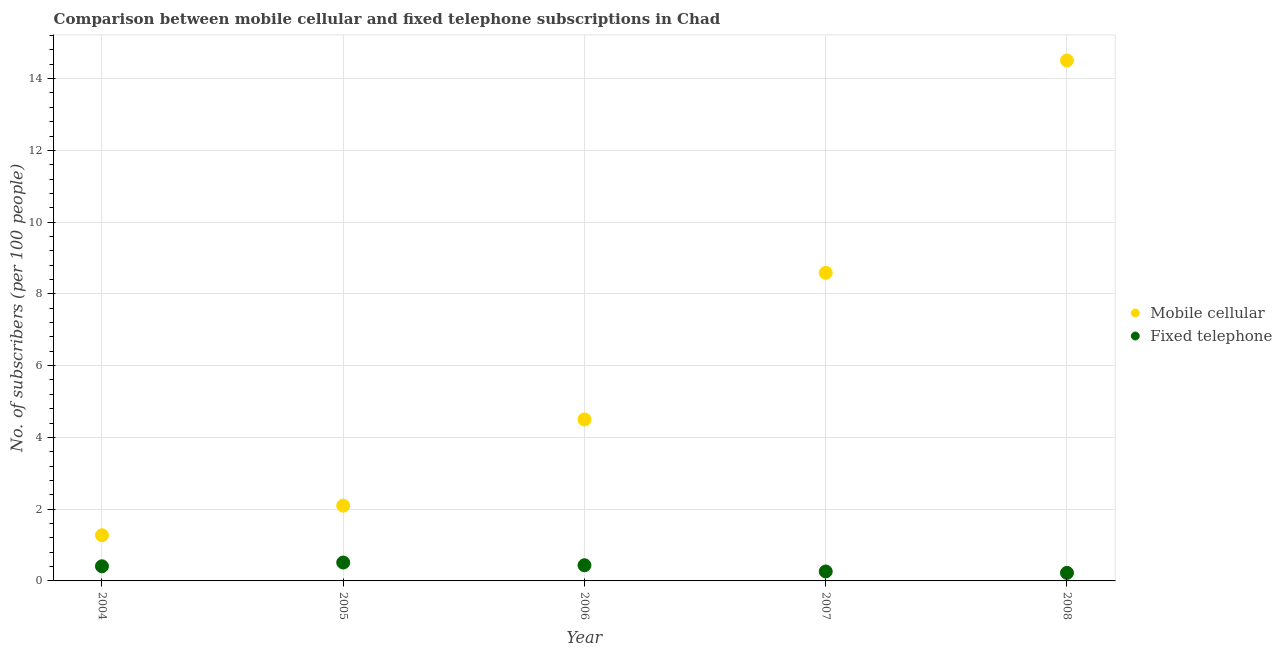How many different coloured dotlines are there?
Offer a terse response. 2. Is the number of dotlines equal to the number of legend labels?
Provide a succinct answer. Yes. What is the number of mobile cellular subscribers in 2004?
Offer a terse response. 1.27. Across all years, what is the maximum number of fixed telephone subscribers?
Your answer should be compact. 0.51. Across all years, what is the minimum number of fixed telephone subscribers?
Your answer should be very brief. 0.22. In which year was the number of fixed telephone subscribers maximum?
Provide a short and direct response. 2005. What is the total number of mobile cellular subscribers in the graph?
Provide a succinct answer. 30.96. What is the difference between the number of mobile cellular subscribers in 2004 and that in 2008?
Provide a succinct answer. -13.23. What is the difference between the number of fixed telephone subscribers in 2007 and the number of mobile cellular subscribers in 2005?
Keep it short and to the point. -1.83. What is the average number of fixed telephone subscribers per year?
Provide a succinct answer. 0.37. In the year 2008, what is the difference between the number of mobile cellular subscribers and number of fixed telephone subscribers?
Your answer should be very brief. 14.28. What is the ratio of the number of fixed telephone subscribers in 2004 to that in 2005?
Your answer should be compact. 0.8. Is the number of mobile cellular subscribers in 2004 less than that in 2006?
Offer a terse response. Yes. Is the difference between the number of fixed telephone subscribers in 2005 and 2008 greater than the difference between the number of mobile cellular subscribers in 2005 and 2008?
Your answer should be very brief. Yes. What is the difference between the highest and the second highest number of fixed telephone subscribers?
Keep it short and to the point. 0.08. What is the difference between the highest and the lowest number of fixed telephone subscribers?
Offer a terse response. 0.29. Is the number of mobile cellular subscribers strictly less than the number of fixed telephone subscribers over the years?
Your answer should be compact. No. How many years are there in the graph?
Offer a terse response. 5. Where does the legend appear in the graph?
Your answer should be very brief. Center right. What is the title of the graph?
Provide a succinct answer. Comparison between mobile cellular and fixed telephone subscriptions in Chad. Does "Private consumption" appear as one of the legend labels in the graph?
Provide a short and direct response. No. What is the label or title of the X-axis?
Ensure brevity in your answer.  Year. What is the label or title of the Y-axis?
Give a very brief answer. No. of subscribers (per 100 people). What is the No. of subscribers (per 100 people) of Mobile cellular in 2004?
Your answer should be compact. 1.27. What is the No. of subscribers (per 100 people) of Fixed telephone in 2004?
Keep it short and to the point. 0.41. What is the No. of subscribers (per 100 people) of Mobile cellular in 2005?
Keep it short and to the point. 2.1. What is the No. of subscribers (per 100 people) of Fixed telephone in 2005?
Keep it short and to the point. 0.51. What is the No. of subscribers (per 100 people) in Mobile cellular in 2006?
Offer a very short reply. 4.5. What is the No. of subscribers (per 100 people) in Fixed telephone in 2006?
Give a very brief answer. 0.44. What is the No. of subscribers (per 100 people) in Mobile cellular in 2007?
Provide a short and direct response. 8.59. What is the No. of subscribers (per 100 people) of Fixed telephone in 2007?
Offer a very short reply. 0.26. What is the No. of subscribers (per 100 people) in Mobile cellular in 2008?
Ensure brevity in your answer.  14.51. What is the No. of subscribers (per 100 people) of Fixed telephone in 2008?
Your response must be concise. 0.22. Across all years, what is the maximum No. of subscribers (per 100 people) in Mobile cellular?
Make the answer very short. 14.51. Across all years, what is the maximum No. of subscribers (per 100 people) in Fixed telephone?
Your answer should be very brief. 0.51. Across all years, what is the minimum No. of subscribers (per 100 people) in Mobile cellular?
Provide a short and direct response. 1.27. Across all years, what is the minimum No. of subscribers (per 100 people) of Fixed telephone?
Offer a terse response. 0.22. What is the total No. of subscribers (per 100 people) of Mobile cellular in the graph?
Your answer should be very brief. 30.96. What is the total No. of subscribers (per 100 people) of Fixed telephone in the graph?
Make the answer very short. 1.85. What is the difference between the No. of subscribers (per 100 people) in Mobile cellular in 2004 and that in 2005?
Your response must be concise. -0.82. What is the difference between the No. of subscribers (per 100 people) of Fixed telephone in 2004 and that in 2005?
Offer a very short reply. -0.1. What is the difference between the No. of subscribers (per 100 people) in Mobile cellular in 2004 and that in 2006?
Offer a very short reply. -3.23. What is the difference between the No. of subscribers (per 100 people) in Fixed telephone in 2004 and that in 2006?
Your answer should be very brief. -0.03. What is the difference between the No. of subscribers (per 100 people) of Mobile cellular in 2004 and that in 2007?
Keep it short and to the point. -7.31. What is the difference between the No. of subscribers (per 100 people) in Fixed telephone in 2004 and that in 2007?
Your answer should be compact. 0.14. What is the difference between the No. of subscribers (per 100 people) in Mobile cellular in 2004 and that in 2008?
Your response must be concise. -13.23. What is the difference between the No. of subscribers (per 100 people) in Fixed telephone in 2004 and that in 2008?
Provide a short and direct response. 0.18. What is the difference between the No. of subscribers (per 100 people) of Mobile cellular in 2005 and that in 2006?
Keep it short and to the point. -2.4. What is the difference between the No. of subscribers (per 100 people) of Fixed telephone in 2005 and that in 2006?
Your answer should be very brief. 0.08. What is the difference between the No. of subscribers (per 100 people) of Mobile cellular in 2005 and that in 2007?
Provide a short and direct response. -6.49. What is the difference between the No. of subscribers (per 100 people) in Fixed telephone in 2005 and that in 2007?
Your response must be concise. 0.25. What is the difference between the No. of subscribers (per 100 people) of Mobile cellular in 2005 and that in 2008?
Give a very brief answer. -12.41. What is the difference between the No. of subscribers (per 100 people) in Fixed telephone in 2005 and that in 2008?
Keep it short and to the point. 0.29. What is the difference between the No. of subscribers (per 100 people) in Mobile cellular in 2006 and that in 2007?
Your answer should be compact. -4.09. What is the difference between the No. of subscribers (per 100 people) of Fixed telephone in 2006 and that in 2007?
Provide a short and direct response. 0.17. What is the difference between the No. of subscribers (per 100 people) of Mobile cellular in 2006 and that in 2008?
Your response must be concise. -10. What is the difference between the No. of subscribers (per 100 people) of Fixed telephone in 2006 and that in 2008?
Keep it short and to the point. 0.21. What is the difference between the No. of subscribers (per 100 people) in Mobile cellular in 2007 and that in 2008?
Make the answer very short. -5.92. What is the difference between the No. of subscribers (per 100 people) of Fixed telephone in 2007 and that in 2008?
Offer a terse response. 0.04. What is the difference between the No. of subscribers (per 100 people) in Mobile cellular in 2004 and the No. of subscribers (per 100 people) in Fixed telephone in 2005?
Your answer should be compact. 0.76. What is the difference between the No. of subscribers (per 100 people) in Mobile cellular in 2004 and the No. of subscribers (per 100 people) in Fixed telephone in 2006?
Give a very brief answer. 0.84. What is the difference between the No. of subscribers (per 100 people) of Mobile cellular in 2004 and the No. of subscribers (per 100 people) of Fixed telephone in 2007?
Offer a very short reply. 1.01. What is the difference between the No. of subscribers (per 100 people) of Mobile cellular in 2004 and the No. of subscribers (per 100 people) of Fixed telephone in 2008?
Your response must be concise. 1.05. What is the difference between the No. of subscribers (per 100 people) of Mobile cellular in 2005 and the No. of subscribers (per 100 people) of Fixed telephone in 2006?
Your answer should be compact. 1.66. What is the difference between the No. of subscribers (per 100 people) in Mobile cellular in 2005 and the No. of subscribers (per 100 people) in Fixed telephone in 2007?
Your answer should be very brief. 1.83. What is the difference between the No. of subscribers (per 100 people) of Mobile cellular in 2005 and the No. of subscribers (per 100 people) of Fixed telephone in 2008?
Keep it short and to the point. 1.87. What is the difference between the No. of subscribers (per 100 people) of Mobile cellular in 2006 and the No. of subscribers (per 100 people) of Fixed telephone in 2007?
Your response must be concise. 4.24. What is the difference between the No. of subscribers (per 100 people) of Mobile cellular in 2006 and the No. of subscribers (per 100 people) of Fixed telephone in 2008?
Your answer should be compact. 4.28. What is the difference between the No. of subscribers (per 100 people) of Mobile cellular in 2007 and the No. of subscribers (per 100 people) of Fixed telephone in 2008?
Give a very brief answer. 8.36. What is the average No. of subscribers (per 100 people) of Mobile cellular per year?
Provide a succinct answer. 6.19. What is the average No. of subscribers (per 100 people) of Fixed telephone per year?
Offer a very short reply. 0.37. In the year 2004, what is the difference between the No. of subscribers (per 100 people) of Mobile cellular and No. of subscribers (per 100 people) of Fixed telephone?
Provide a succinct answer. 0.86. In the year 2005, what is the difference between the No. of subscribers (per 100 people) in Mobile cellular and No. of subscribers (per 100 people) in Fixed telephone?
Provide a short and direct response. 1.58. In the year 2006, what is the difference between the No. of subscribers (per 100 people) of Mobile cellular and No. of subscribers (per 100 people) of Fixed telephone?
Your response must be concise. 4.06. In the year 2007, what is the difference between the No. of subscribers (per 100 people) in Mobile cellular and No. of subscribers (per 100 people) in Fixed telephone?
Offer a terse response. 8.32. In the year 2008, what is the difference between the No. of subscribers (per 100 people) of Mobile cellular and No. of subscribers (per 100 people) of Fixed telephone?
Keep it short and to the point. 14.28. What is the ratio of the No. of subscribers (per 100 people) in Mobile cellular in 2004 to that in 2005?
Your answer should be very brief. 0.61. What is the ratio of the No. of subscribers (per 100 people) of Fixed telephone in 2004 to that in 2005?
Ensure brevity in your answer.  0.8. What is the ratio of the No. of subscribers (per 100 people) of Mobile cellular in 2004 to that in 2006?
Your answer should be very brief. 0.28. What is the ratio of the No. of subscribers (per 100 people) of Fixed telephone in 2004 to that in 2006?
Your answer should be very brief. 0.93. What is the ratio of the No. of subscribers (per 100 people) of Mobile cellular in 2004 to that in 2007?
Make the answer very short. 0.15. What is the ratio of the No. of subscribers (per 100 people) in Fixed telephone in 2004 to that in 2007?
Offer a very short reply. 1.55. What is the ratio of the No. of subscribers (per 100 people) in Mobile cellular in 2004 to that in 2008?
Provide a succinct answer. 0.09. What is the ratio of the No. of subscribers (per 100 people) of Fixed telephone in 2004 to that in 2008?
Keep it short and to the point. 1.82. What is the ratio of the No. of subscribers (per 100 people) of Mobile cellular in 2005 to that in 2006?
Provide a short and direct response. 0.47. What is the ratio of the No. of subscribers (per 100 people) in Fixed telephone in 2005 to that in 2006?
Your answer should be very brief. 1.17. What is the ratio of the No. of subscribers (per 100 people) of Mobile cellular in 2005 to that in 2007?
Provide a succinct answer. 0.24. What is the ratio of the No. of subscribers (per 100 people) in Fixed telephone in 2005 to that in 2007?
Offer a very short reply. 1.94. What is the ratio of the No. of subscribers (per 100 people) in Mobile cellular in 2005 to that in 2008?
Make the answer very short. 0.14. What is the ratio of the No. of subscribers (per 100 people) of Fixed telephone in 2005 to that in 2008?
Keep it short and to the point. 2.28. What is the ratio of the No. of subscribers (per 100 people) in Mobile cellular in 2006 to that in 2007?
Your response must be concise. 0.52. What is the ratio of the No. of subscribers (per 100 people) of Fixed telephone in 2006 to that in 2007?
Give a very brief answer. 1.66. What is the ratio of the No. of subscribers (per 100 people) of Mobile cellular in 2006 to that in 2008?
Your response must be concise. 0.31. What is the ratio of the No. of subscribers (per 100 people) in Fixed telephone in 2006 to that in 2008?
Offer a very short reply. 1.95. What is the ratio of the No. of subscribers (per 100 people) of Mobile cellular in 2007 to that in 2008?
Ensure brevity in your answer.  0.59. What is the ratio of the No. of subscribers (per 100 people) of Fixed telephone in 2007 to that in 2008?
Offer a terse response. 1.17. What is the difference between the highest and the second highest No. of subscribers (per 100 people) in Mobile cellular?
Make the answer very short. 5.92. What is the difference between the highest and the second highest No. of subscribers (per 100 people) in Fixed telephone?
Offer a terse response. 0.08. What is the difference between the highest and the lowest No. of subscribers (per 100 people) of Mobile cellular?
Your response must be concise. 13.23. What is the difference between the highest and the lowest No. of subscribers (per 100 people) of Fixed telephone?
Provide a succinct answer. 0.29. 